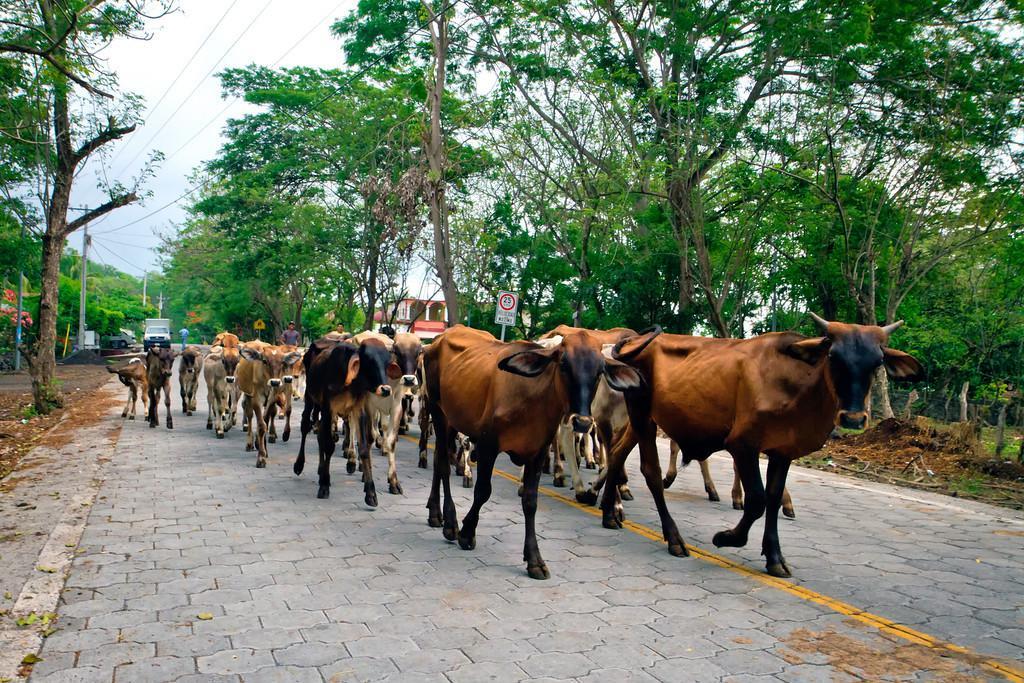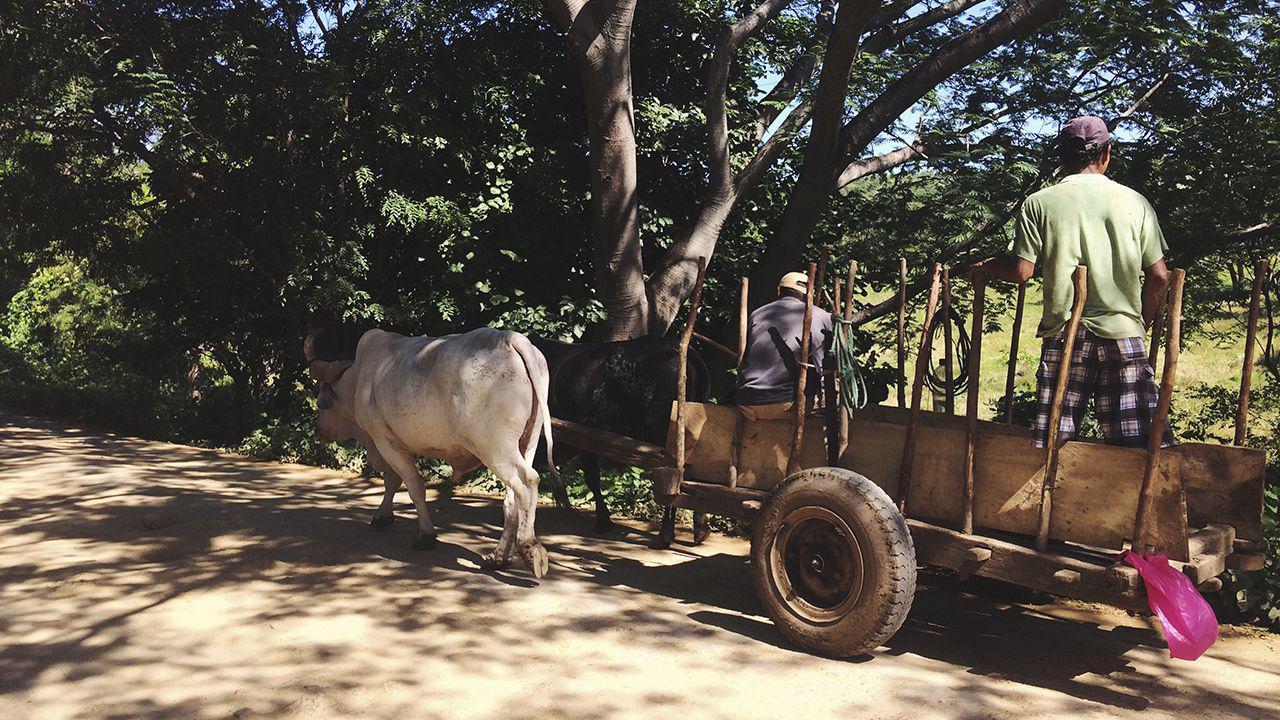The first image is the image on the left, the second image is the image on the right. Given the left and right images, does the statement "All of the animals are walking." hold true? Answer yes or no. Yes. The first image is the image on the left, the second image is the image on the right. Considering the images on both sides, is "All the cows in the image are attached to, and pulling, something behind them." valid? Answer yes or no. No. 